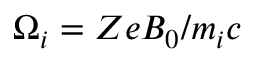<formula> <loc_0><loc_0><loc_500><loc_500>\Omega _ { i } = Z e B _ { 0 } / m _ { i } c</formula> 